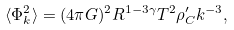Convert formula to latex. <formula><loc_0><loc_0><loc_500><loc_500>\langle \Phi _ { k } ^ { 2 } \rangle = ( 4 \pi G ) ^ { 2 } R ^ { 1 - 3 \gamma } T ^ { 2 } \rho ^ { \prime } _ { C } k ^ { - 3 } ,</formula> 